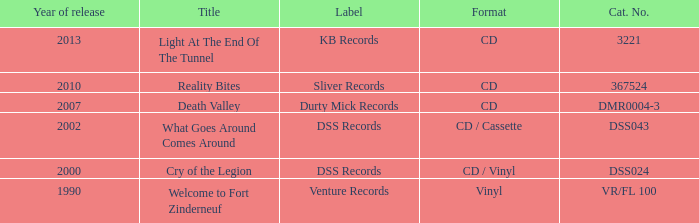What is the total year of release of the title what goes around comes around? 1.0. 